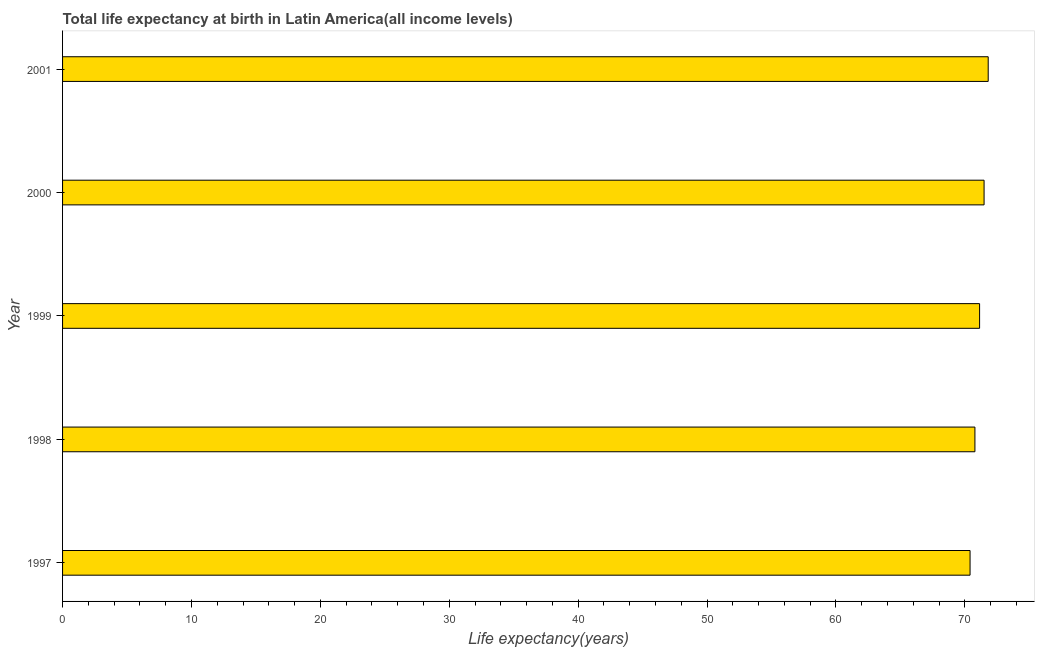Does the graph contain grids?
Your response must be concise. No. What is the title of the graph?
Offer a very short reply. Total life expectancy at birth in Latin America(all income levels). What is the label or title of the X-axis?
Ensure brevity in your answer.  Life expectancy(years). What is the life expectancy at birth in 1999?
Keep it short and to the point. 71.15. Across all years, what is the maximum life expectancy at birth?
Provide a short and direct response. 71.82. Across all years, what is the minimum life expectancy at birth?
Your answer should be very brief. 70.41. In which year was the life expectancy at birth maximum?
Offer a very short reply. 2001. What is the sum of the life expectancy at birth?
Offer a very short reply. 355.66. What is the difference between the life expectancy at birth in 2000 and 2001?
Provide a short and direct response. -0.32. What is the average life expectancy at birth per year?
Provide a short and direct response. 71.13. What is the median life expectancy at birth?
Make the answer very short. 71.15. In how many years, is the life expectancy at birth greater than 34 years?
Your response must be concise. 5. Do a majority of the years between 1998 and 2001 (inclusive) have life expectancy at birth greater than 52 years?
Your answer should be very brief. Yes. What is the ratio of the life expectancy at birth in 1997 to that in 1998?
Your answer should be compact. 0.99. Is the difference between the life expectancy at birth in 1998 and 1999 greater than the difference between any two years?
Provide a succinct answer. No. What is the difference between the highest and the second highest life expectancy at birth?
Make the answer very short. 0.32. What is the difference between the highest and the lowest life expectancy at birth?
Keep it short and to the point. 1.41. In how many years, is the life expectancy at birth greater than the average life expectancy at birth taken over all years?
Keep it short and to the point. 3. How many bars are there?
Offer a terse response. 5. Are all the bars in the graph horizontal?
Offer a terse response. Yes. What is the difference between two consecutive major ticks on the X-axis?
Offer a terse response. 10. Are the values on the major ticks of X-axis written in scientific E-notation?
Give a very brief answer. No. What is the Life expectancy(years) of 1997?
Provide a short and direct response. 70.41. What is the Life expectancy(years) in 1998?
Provide a succinct answer. 70.79. What is the Life expectancy(years) in 1999?
Give a very brief answer. 71.15. What is the Life expectancy(years) of 2000?
Your answer should be compact. 71.5. What is the Life expectancy(years) in 2001?
Ensure brevity in your answer.  71.82. What is the difference between the Life expectancy(years) in 1997 and 1998?
Your answer should be compact. -0.38. What is the difference between the Life expectancy(years) in 1997 and 1999?
Ensure brevity in your answer.  -0.74. What is the difference between the Life expectancy(years) in 1997 and 2000?
Offer a terse response. -1.09. What is the difference between the Life expectancy(years) in 1997 and 2001?
Your response must be concise. -1.41. What is the difference between the Life expectancy(years) in 1998 and 1999?
Provide a succinct answer. -0.36. What is the difference between the Life expectancy(years) in 1998 and 2000?
Your response must be concise. -0.71. What is the difference between the Life expectancy(years) in 1998 and 2001?
Keep it short and to the point. -1.03. What is the difference between the Life expectancy(years) in 1999 and 2000?
Your answer should be compact. -0.35. What is the difference between the Life expectancy(years) in 1999 and 2001?
Your response must be concise. -0.67. What is the difference between the Life expectancy(years) in 2000 and 2001?
Your answer should be very brief. -0.32. What is the ratio of the Life expectancy(years) in 1997 to that in 1998?
Provide a short and direct response. 0.99. What is the ratio of the Life expectancy(years) in 1997 to that in 2000?
Your response must be concise. 0.98. What is the ratio of the Life expectancy(years) in 1997 to that in 2001?
Offer a terse response. 0.98. What is the ratio of the Life expectancy(years) in 1998 to that in 1999?
Your answer should be very brief. 0.99. What is the ratio of the Life expectancy(years) in 1998 to that in 2001?
Provide a short and direct response. 0.99. What is the ratio of the Life expectancy(years) in 1999 to that in 2000?
Offer a very short reply. 0.99. What is the ratio of the Life expectancy(years) in 1999 to that in 2001?
Your response must be concise. 0.99. What is the ratio of the Life expectancy(years) in 2000 to that in 2001?
Your answer should be compact. 1. 